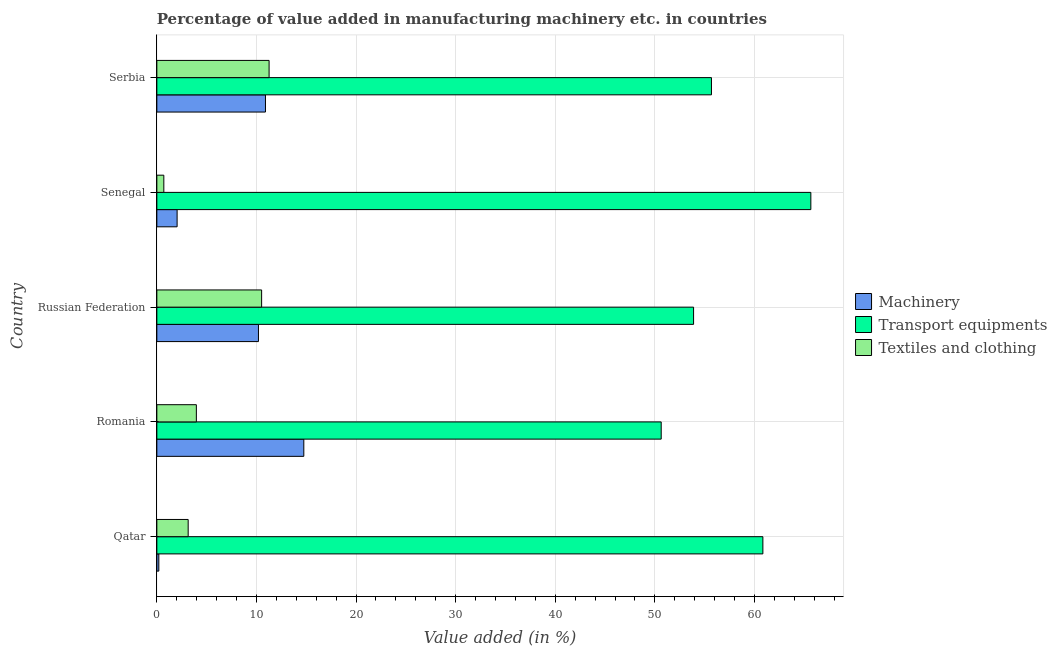How many different coloured bars are there?
Ensure brevity in your answer.  3. How many groups of bars are there?
Make the answer very short. 5. Are the number of bars per tick equal to the number of legend labels?
Ensure brevity in your answer.  Yes. How many bars are there on the 5th tick from the top?
Your answer should be very brief. 3. How many bars are there on the 4th tick from the bottom?
Offer a terse response. 3. What is the label of the 2nd group of bars from the top?
Ensure brevity in your answer.  Senegal. In how many cases, is the number of bars for a given country not equal to the number of legend labels?
Offer a terse response. 0. What is the value added in manufacturing textile and clothing in Serbia?
Give a very brief answer. 11.27. Across all countries, what is the maximum value added in manufacturing textile and clothing?
Provide a short and direct response. 11.27. Across all countries, what is the minimum value added in manufacturing machinery?
Provide a short and direct response. 0.2. In which country was the value added in manufacturing textile and clothing maximum?
Give a very brief answer. Serbia. In which country was the value added in manufacturing machinery minimum?
Ensure brevity in your answer.  Qatar. What is the total value added in manufacturing transport equipments in the graph?
Provide a succinct answer. 286.72. What is the difference between the value added in manufacturing machinery in Russian Federation and that in Serbia?
Your answer should be very brief. -0.7. What is the difference between the value added in manufacturing textile and clothing in Russian Federation and the value added in manufacturing machinery in Serbia?
Give a very brief answer. -0.38. What is the average value added in manufacturing textile and clothing per country?
Provide a short and direct response. 5.92. What is the difference between the value added in manufacturing machinery and value added in manufacturing transport equipments in Senegal?
Your answer should be compact. -63.63. In how many countries, is the value added in manufacturing machinery greater than 58 %?
Your answer should be compact. 0. What is the ratio of the value added in manufacturing textile and clothing in Romania to that in Serbia?
Make the answer very short. 0.35. What is the difference between the highest and the second highest value added in manufacturing machinery?
Your answer should be very brief. 3.85. What is the difference between the highest and the lowest value added in manufacturing textile and clothing?
Your response must be concise. 10.57. What does the 1st bar from the top in Serbia represents?
Provide a short and direct response. Textiles and clothing. What does the 1st bar from the bottom in Romania represents?
Ensure brevity in your answer.  Machinery. Is it the case that in every country, the sum of the value added in manufacturing machinery and value added in manufacturing transport equipments is greater than the value added in manufacturing textile and clothing?
Give a very brief answer. Yes. How many bars are there?
Offer a terse response. 15. Are all the bars in the graph horizontal?
Ensure brevity in your answer.  Yes. Does the graph contain any zero values?
Ensure brevity in your answer.  No. Does the graph contain grids?
Keep it short and to the point. Yes. Where does the legend appear in the graph?
Provide a succinct answer. Center right. How many legend labels are there?
Offer a terse response. 3. What is the title of the graph?
Ensure brevity in your answer.  Percentage of value added in manufacturing machinery etc. in countries. What is the label or title of the X-axis?
Provide a succinct answer. Value added (in %). What is the Value added (in %) in Machinery in Qatar?
Provide a succinct answer. 0.2. What is the Value added (in %) in Transport equipments in Qatar?
Offer a terse response. 60.85. What is the Value added (in %) of Textiles and clothing in Qatar?
Your answer should be very brief. 3.14. What is the Value added (in %) of Machinery in Romania?
Provide a succinct answer. 14.75. What is the Value added (in %) in Transport equipments in Romania?
Give a very brief answer. 50.64. What is the Value added (in %) of Textiles and clothing in Romania?
Provide a succinct answer. 3.97. What is the Value added (in %) of Machinery in Russian Federation?
Your answer should be very brief. 10.2. What is the Value added (in %) of Transport equipments in Russian Federation?
Give a very brief answer. 53.89. What is the Value added (in %) in Textiles and clothing in Russian Federation?
Offer a very short reply. 10.52. What is the Value added (in %) of Machinery in Senegal?
Offer a terse response. 2.03. What is the Value added (in %) in Transport equipments in Senegal?
Give a very brief answer. 65.66. What is the Value added (in %) in Textiles and clothing in Senegal?
Give a very brief answer. 0.7. What is the Value added (in %) of Machinery in Serbia?
Keep it short and to the point. 10.91. What is the Value added (in %) in Transport equipments in Serbia?
Provide a succinct answer. 55.68. What is the Value added (in %) in Textiles and clothing in Serbia?
Keep it short and to the point. 11.27. Across all countries, what is the maximum Value added (in %) in Machinery?
Keep it short and to the point. 14.75. Across all countries, what is the maximum Value added (in %) of Transport equipments?
Your answer should be very brief. 65.66. Across all countries, what is the maximum Value added (in %) of Textiles and clothing?
Your answer should be very brief. 11.27. Across all countries, what is the minimum Value added (in %) in Machinery?
Offer a terse response. 0.2. Across all countries, what is the minimum Value added (in %) of Transport equipments?
Ensure brevity in your answer.  50.64. Across all countries, what is the minimum Value added (in %) of Textiles and clothing?
Your response must be concise. 0.7. What is the total Value added (in %) of Machinery in the graph?
Give a very brief answer. 38.09. What is the total Value added (in %) of Transport equipments in the graph?
Offer a terse response. 286.72. What is the total Value added (in %) of Textiles and clothing in the graph?
Make the answer very short. 29.6. What is the difference between the Value added (in %) of Machinery in Qatar and that in Romania?
Ensure brevity in your answer.  -14.56. What is the difference between the Value added (in %) in Transport equipments in Qatar and that in Romania?
Provide a succinct answer. 10.21. What is the difference between the Value added (in %) of Textiles and clothing in Qatar and that in Romania?
Your answer should be very brief. -0.82. What is the difference between the Value added (in %) of Machinery in Qatar and that in Russian Federation?
Offer a very short reply. -10. What is the difference between the Value added (in %) of Transport equipments in Qatar and that in Russian Federation?
Offer a terse response. 6.96. What is the difference between the Value added (in %) of Textiles and clothing in Qatar and that in Russian Federation?
Ensure brevity in your answer.  -7.38. What is the difference between the Value added (in %) in Machinery in Qatar and that in Senegal?
Your answer should be compact. -1.84. What is the difference between the Value added (in %) of Transport equipments in Qatar and that in Senegal?
Ensure brevity in your answer.  -4.82. What is the difference between the Value added (in %) in Textiles and clothing in Qatar and that in Senegal?
Offer a very short reply. 2.44. What is the difference between the Value added (in %) in Machinery in Qatar and that in Serbia?
Your answer should be compact. -10.71. What is the difference between the Value added (in %) in Transport equipments in Qatar and that in Serbia?
Offer a very short reply. 5.16. What is the difference between the Value added (in %) in Textiles and clothing in Qatar and that in Serbia?
Your answer should be compact. -8.13. What is the difference between the Value added (in %) in Machinery in Romania and that in Russian Federation?
Provide a short and direct response. 4.55. What is the difference between the Value added (in %) of Transport equipments in Romania and that in Russian Federation?
Provide a succinct answer. -3.25. What is the difference between the Value added (in %) in Textiles and clothing in Romania and that in Russian Federation?
Keep it short and to the point. -6.55. What is the difference between the Value added (in %) of Machinery in Romania and that in Senegal?
Your answer should be very brief. 12.72. What is the difference between the Value added (in %) of Transport equipments in Romania and that in Senegal?
Your response must be concise. -15.02. What is the difference between the Value added (in %) in Textiles and clothing in Romania and that in Senegal?
Your answer should be very brief. 3.27. What is the difference between the Value added (in %) in Machinery in Romania and that in Serbia?
Make the answer very short. 3.85. What is the difference between the Value added (in %) in Transport equipments in Romania and that in Serbia?
Make the answer very short. -5.05. What is the difference between the Value added (in %) in Textiles and clothing in Romania and that in Serbia?
Give a very brief answer. -7.3. What is the difference between the Value added (in %) in Machinery in Russian Federation and that in Senegal?
Provide a succinct answer. 8.17. What is the difference between the Value added (in %) in Transport equipments in Russian Federation and that in Senegal?
Keep it short and to the point. -11.77. What is the difference between the Value added (in %) in Textiles and clothing in Russian Federation and that in Senegal?
Your answer should be very brief. 9.82. What is the difference between the Value added (in %) of Machinery in Russian Federation and that in Serbia?
Make the answer very short. -0.7. What is the difference between the Value added (in %) of Transport equipments in Russian Federation and that in Serbia?
Keep it short and to the point. -1.79. What is the difference between the Value added (in %) of Textiles and clothing in Russian Federation and that in Serbia?
Your answer should be compact. -0.75. What is the difference between the Value added (in %) in Machinery in Senegal and that in Serbia?
Your answer should be compact. -8.87. What is the difference between the Value added (in %) of Transport equipments in Senegal and that in Serbia?
Provide a succinct answer. 9.98. What is the difference between the Value added (in %) of Textiles and clothing in Senegal and that in Serbia?
Ensure brevity in your answer.  -10.57. What is the difference between the Value added (in %) in Machinery in Qatar and the Value added (in %) in Transport equipments in Romania?
Provide a short and direct response. -50.44. What is the difference between the Value added (in %) in Machinery in Qatar and the Value added (in %) in Textiles and clothing in Romania?
Provide a short and direct response. -3.77. What is the difference between the Value added (in %) of Transport equipments in Qatar and the Value added (in %) of Textiles and clothing in Romania?
Make the answer very short. 56.88. What is the difference between the Value added (in %) of Machinery in Qatar and the Value added (in %) of Transport equipments in Russian Federation?
Offer a very short reply. -53.69. What is the difference between the Value added (in %) in Machinery in Qatar and the Value added (in %) in Textiles and clothing in Russian Federation?
Your answer should be very brief. -10.32. What is the difference between the Value added (in %) in Transport equipments in Qatar and the Value added (in %) in Textiles and clothing in Russian Federation?
Ensure brevity in your answer.  50.33. What is the difference between the Value added (in %) of Machinery in Qatar and the Value added (in %) of Transport equipments in Senegal?
Keep it short and to the point. -65.46. What is the difference between the Value added (in %) in Machinery in Qatar and the Value added (in %) in Textiles and clothing in Senegal?
Offer a terse response. -0.5. What is the difference between the Value added (in %) of Transport equipments in Qatar and the Value added (in %) of Textiles and clothing in Senegal?
Provide a short and direct response. 60.15. What is the difference between the Value added (in %) in Machinery in Qatar and the Value added (in %) in Transport equipments in Serbia?
Provide a short and direct response. -55.48. What is the difference between the Value added (in %) of Machinery in Qatar and the Value added (in %) of Textiles and clothing in Serbia?
Provide a short and direct response. -11.07. What is the difference between the Value added (in %) of Transport equipments in Qatar and the Value added (in %) of Textiles and clothing in Serbia?
Keep it short and to the point. 49.58. What is the difference between the Value added (in %) of Machinery in Romania and the Value added (in %) of Transport equipments in Russian Federation?
Make the answer very short. -39.13. What is the difference between the Value added (in %) in Machinery in Romania and the Value added (in %) in Textiles and clothing in Russian Federation?
Give a very brief answer. 4.23. What is the difference between the Value added (in %) in Transport equipments in Romania and the Value added (in %) in Textiles and clothing in Russian Federation?
Provide a succinct answer. 40.12. What is the difference between the Value added (in %) of Machinery in Romania and the Value added (in %) of Transport equipments in Senegal?
Your answer should be compact. -50.91. What is the difference between the Value added (in %) of Machinery in Romania and the Value added (in %) of Textiles and clothing in Senegal?
Your answer should be very brief. 14.05. What is the difference between the Value added (in %) of Transport equipments in Romania and the Value added (in %) of Textiles and clothing in Senegal?
Provide a short and direct response. 49.94. What is the difference between the Value added (in %) of Machinery in Romania and the Value added (in %) of Transport equipments in Serbia?
Your answer should be very brief. -40.93. What is the difference between the Value added (in %) of Machinery in Romania and the Value added (in %) of Textiles and clothing in Serbia?
Your answer should be very brief. 3.48. What is the difference between the Value added (in %) in Transport equipments in Romania and the Value added (in %) in Textiles and clothing in Serbia?
Keep it short and to the point. 39.37. What is the difference between the Value added (in %) of Machinery in Russian Federation and the Value added (in %) of Transport equipments in Senegal?
Provide a succinct answer. -55.46. What is the difference between the Value added (in %) in Machinery in Russian Federation and the Value added (in %) in Textiles and clothing in Senegal?
Provide a succinct answer. 9.5. What is the difference between the Value added (in %) in Transport equipments in Russian Federation and the Value added (in %) in Textiles and clothing in Senegal?
Ensure brevity in your answer.  53.19. What is the difference between the Value added (in %) of Machinery in Russian Federation and the Value added (in %) of Transport equipments in Serbia?
Provide a short and direct response. -45.48. What is the difference between the Value added (in %) in Machinery in Russian Federation and the Value added (in %) in Textiles and clothing in Serbia?
Give a very brief answer. -1.07. What is the difference between the Value added (in %) of Transport equipments in Russian Federation and the Value added (in %) of Textiles and clothing in Serbia?
Your answer should be compact. 42.62. What is the difference between the Value added (in %) of Machinery in Senegal and the Value added (in %) of Transport equipments in Serbia?
Your response must be concise. -53.65. What is the difference between the Value added (in %) of Machinery in Senegal and the Value added (in %) of Textiles and clothing in Serbia?
Your answer should be very brief. -9.24. What is the difference between the Value added (in %) in Transport equipments in Senegal and the Value added (in %) in Textiles and clothing in Serbia?
Provide a succinct answer. 54.39. What is the average Value added (in %) of Machinery per country?
Provide a succinct answer. 7.62. What is the average Value added (in %) of Transport equipments per country?
Keep it short and to the point. 57.34. What is the average Value added (in %) of Textiles and clothing per country?
Your answer should be compact. 5.92. What is the difference between the Value added (in %) in Machinery and Value added (in %) in Transport equipments in Qatar?
Offer a terse response. -60.65. What is the difference between the Value added (in %) in Machinery and Value added (in %) in Textiles and clothing in Qatar?
Provide a succinct answer. -2.95. What is the difference between the Value added (in %) of Transport equipments and Value added (in %) of Textiles and clothing in Qatar?
Provide a short and direct response. 57.7. What is the difference between the Value added (in %) of Machinery and Value added (in %) of Transport equipments in Romania?
Keep it short and to the point. -35.88. What is the difference between the Value added (in %) of Machinery and Value added (in %) of Textiles and clothing in Romania?
Ensure brevity in your answer.  10.79. What is the difference between the Value added (in %) of Transport equipments and Value added (in %) of Textiles and clothing in Romania?
Your answer should be compact. 46.67. What is the difference between the Value added (in %) in Machinery and Value added (in %) in Transport equipments in Russian Federation?
Ensure brevity in your answer.  -43.69. What is the difference between the Value added (in %) in Machinery and Value added (in %) in Textiles and clothing in Russian Federation?
Make the answer very short. -0.32. What is the difference between the Value added (in %) in Transport equipments and Value added (in %) in Textiles and clothing in Russian Federation?
Provide a succinct answer. 43.37. What is the difference between the Value added (in %) in Machinery and Value added (in %) in Transport equipments in Senegal?
Make the answer very short. -63.63. What is the difference between the Value added (in %) of Machinery and Value added (in %) of Textiles and clothing in Senegal?
Provide a short and direct response. 1.33. What is the difference between the Value added (in %) in Transport equipments and Value added (in %) in Textiles and clothing in Senegal?
Offer a terse response. 64.96. What is the difference between the Value added (in %) in Machinery and Value added (in %) in Transport equipments in Serbia?
Give a very brief answer. -44.78. What is the difference between the Value added (in %) in Machinery and Value added (in %) in Textiles and clothing in Serbia?
Keep it short and to the point. -0.36. What is the difference between the Value added (in %) in Transport equipments and Value added (in %) in Textiles and clothing in Serbia?
Keep it short and to the point. 44.41. What is the ratio of the Value added (in %) of Machinery in Qatar to that in Romania?
Offer a very short reply. 0.01. What is the ratio of the Value added (in %) of Transport equipments in Qatar to that in Romania?
Provide a succinct answer. 1.2. What is the ratio of the Value added (in %) of Textiles and clothing in Qatar to that in Romania?
Your answer should be very brief. 0.79. What is the ratio of the Value added (in %) in Machinery in Qatar to that in Russian Federation?
Give a very brief answer. 0.02. What is the ratio of the Value added (in %) of Transport equipments in Qatar to that in Russian Federation?
Your answer should be very brief. 1.13. What is the ratio of the Value added (in %) of Textiles and clothing in Qatar to that in Russian Federation?
Your answer should be compact. 0.3. What is the ratio of the Value added (in %) in Machinery in Qatar to that in Senegal?
Offer a terse response. 0.1. What is the ratio of the Value added (in %) in Transport equipments in Qatar to that in Senegal?
Offer a terse response. 0.93. What is the ratio of the Value added (in %) in Textiles and clothing in Qatar to that in Senegal?
Your answer should be very brief. 4.49. What is the ratio of the Value added (in %) in Machinery in Qatar to that in Serbia?
Give a very brief answer. 0.02. What is the ratio of the Value added (in %) in Transport equipments in Qatar to that in Serbia?
Ensure brevity in your answer.  1.09. What is the ratio of the Value added (in %) of Textiles and clothing in Qatar to that in Serbia?
Provide a succinct answer. 0.28. What is the ratio of the Value added (in %) of Machinery in Romania to that in Russian Federation?
Your response must be concise. 1.45. What is the ratio of the Value added (in %) in Transport equipments in Romania to that in Russian Federation?
Make the answer very short. 0.94. What is the ratio of the Value added (in %) of Textiles and clothing in Romania to that in Russian Federation?
Your answer should be compact. 0.38. What is the ratio of the Value added (in %) of Machinery in Romania to that in Senegal?
Offer a very short reply. 7.25. What is the ratio of the Value added (in %) of Transport equipments in Romania to that in Senegal?
Your response must be concise. 0.77. What is the ratio of the Value added (in %) of Textiles and clothing in Romania to that in Senegal?
Provide a succinct answer. 5.66. What is the ratio of the Value added (in %) in Machinery in Romania to that in Serbia?
Keep it short and to the point. 1.35. What is the ratio of the Value added (in %) of Transport equipments in Romania to that in Serbia?
Your response must be concise. 0.91. What is the ratio of the Value added (in %) of Textiles and clothing in Romania to that in Serbia?
Offer a terse response. 0.35. What is the ratio of the Value added (in %) in Machinery in Russian Federation to that in Senegal?
Provide a succinct answer. 5.02. What is the ratio of the Value added (in %) of Transport equipments in Russian Federation to that in Senegal?
Your response must be concise. 0.82. What is the ratio of the Value added (in %) in Textiles and clothing in Russian Federation to that in Senegal?
Provide a succinct answer. 15.02. What is the ratio of the Value added (in %) in Machinery in Russian Federation to that in Serbia?
Make the answer very short. 0.94. What is the ratio of the Value added (in %) in Transport equipments in Russian Federation to that in Serbia?
Make the answer very short. 0.97. What is the ratio of the Value added (in %) in Textiles and clothing in Russian Federation to that in Serbia?
Offer a very short reply. 0.93. What is the ratio of the Value added (in %) in Machinery in Senegal to that in Serbia?
Make the answer very short. 0.19. What is the ratio of the Value added (in %) of Transport equipments in Senegal to that in Serbia?
Make the answer very short. 1.18. What is the ratio of the Value added (in %) of Textiles and clothing in Senegal to that in Serbia?
Provide a short and direct response. 0.06. What is the difference between the highest and the second highest Value added (in %) of Machinery?
Your response must be concise. 3.85. What is the difference between the highest and the second highest Value added (in %) of Transport equipments?
Your answer should be very brief. 4.82. What is the difference between the highest and the second highest Value added (in %) of Textiles and clothing?
Offer a terse response. 0.75. What is the difference between the highest and the lowest Value added (in %) of Machinery?
Ensure brevity in your answer.  14.56. What is the difference between the highest and the lowest Value added (in %) in Transport equipments?
Offer a terse response. 15.02. What is the difference between the highest and the lowest Value added (in %) of Textiles and clothing?
Your answer should be compact. 10.57. 